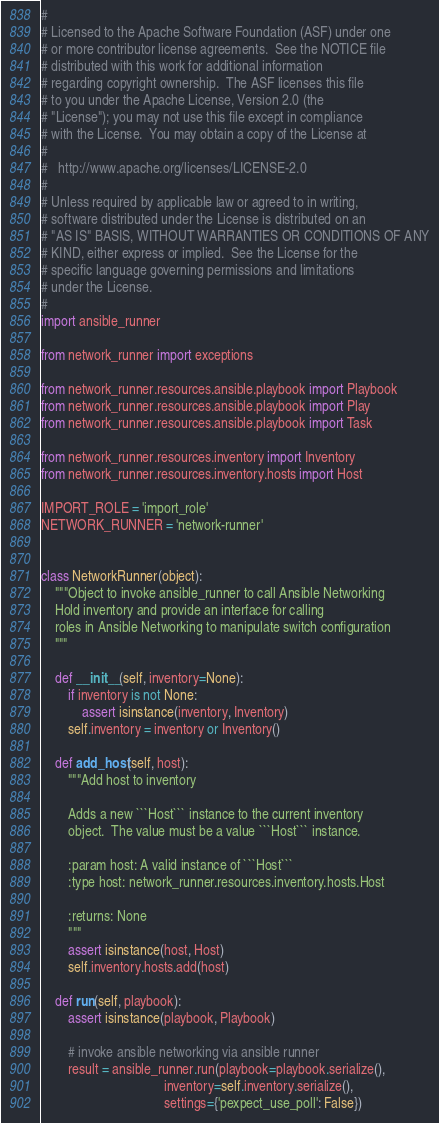Convert code to text. <code><loc_0><loc_0><loc_500><loc_500><_Python_>#
# Licensed to the Apache Software Foundation (ASF) under one
# or more contributor license agreements.  See the NOTICE file
# distributed with this work for additional information
# regarding copyright ownership.  The ASF licenses this file
# to you under the Apache License, Version 2.0 (the
# "License"); you may not use this file except in compliance
# with the License.  You may obtain a copy of the License at
#
#   http://www.apache.org/licenses/LICENSE-2.0
#
# Unless required by applicable law or agreed to in writing,
# software distributed under the License is distributed on an
# "AS IS" BASIS, WITHOUT WARRANTIES OR CONDITIONS OF ANY
# KIND, either express or implied.  See the License for the
# specific language governing permissions and limitations
# under the License.
#
import ansible_runner

from network_runner import exceptions

from network_runner.resources.ansible.playbook import Playbook
from network_runner.resources.ansible.playbook import Play
from network_runner.resources.ansible.playbook import Task

from network_runner.resources.inventory import Inventory
from network_runner.resources.inventory.hosts import Host

IMPORT_ROLE = 'import_role'
NETWORK_RUNNER = 'network-runner'


class NetworkRunner(object):
    """Object to invoke ansible_runner to call Ansible Networking
    Hold inventory and provide an interface for calling
    roles in Ansible Networking to manipulate switch configuration
    """

    def __init__(self, inventory=None):
        if inventory is not None:
            assert isinstance(inventory, Inventory)
        self.inventory = inventory or Inventory()

    def add_host(self, host):
        """Add host to inventory

        Adds a new ```Host``` instance to the current inventory
        object.  The value must be a value ```Host``` instance.

        :param host: A valid instance of ```Host```
        :type host: network_runner.resources.inventory.hosts.Host

        :returns: None
        """
        assert isinstance(host, Host)
        self.inventory.hosts.add(host)

    def run(self, playbook):
        assert isinstance(playbook, Playbook)

        # invoke ansible networking via ansible runner
        result = ansible_runner.run(playbook=playbook.serialize(),
                                    inventory=self.inventory.serialize(),
                                    settings={'pexpect_use_poll': False})
</code> 